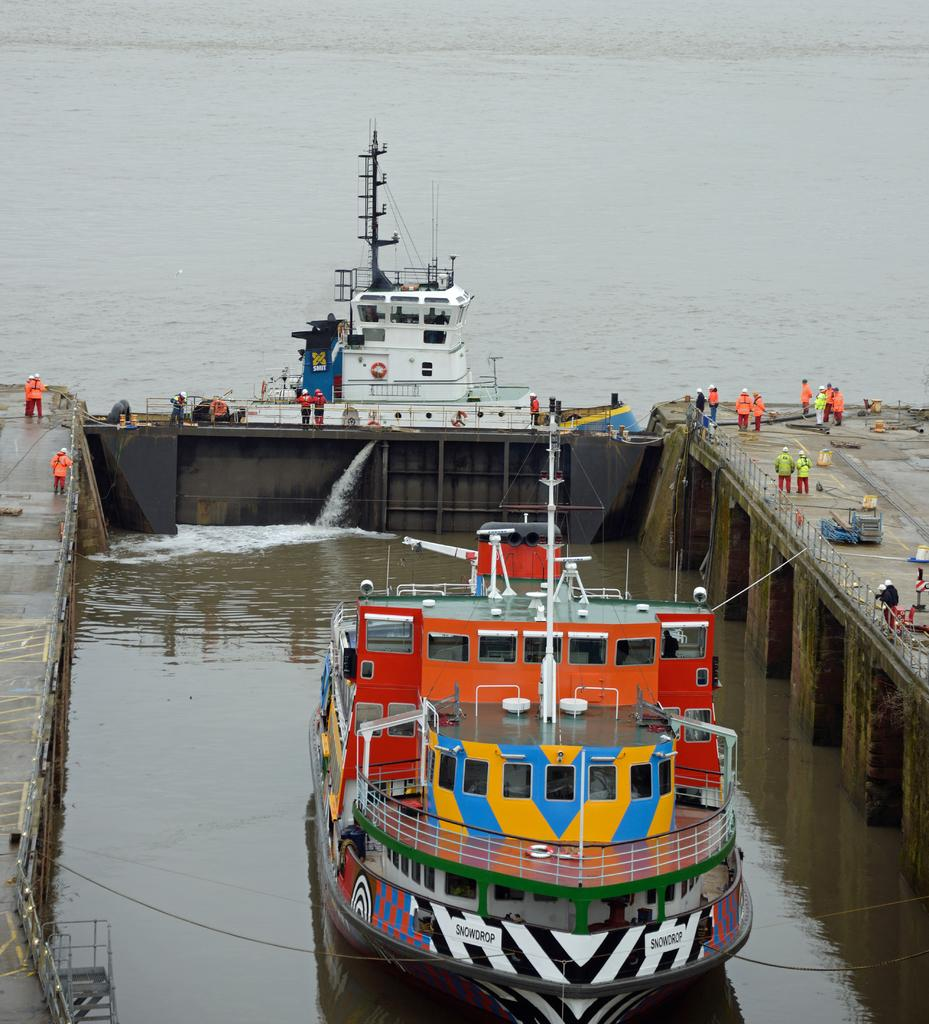What is the main subject in the center of the image? There are ships in the center of the image. Where are people located in the image? People are on the docks on both the right and left sides of the image. What is the surrounding environment in the image? There is water around the area of the image. What type of string is being used by the people on the docks in the image? There is no string visible in the image; people are simply standing on the docks. 